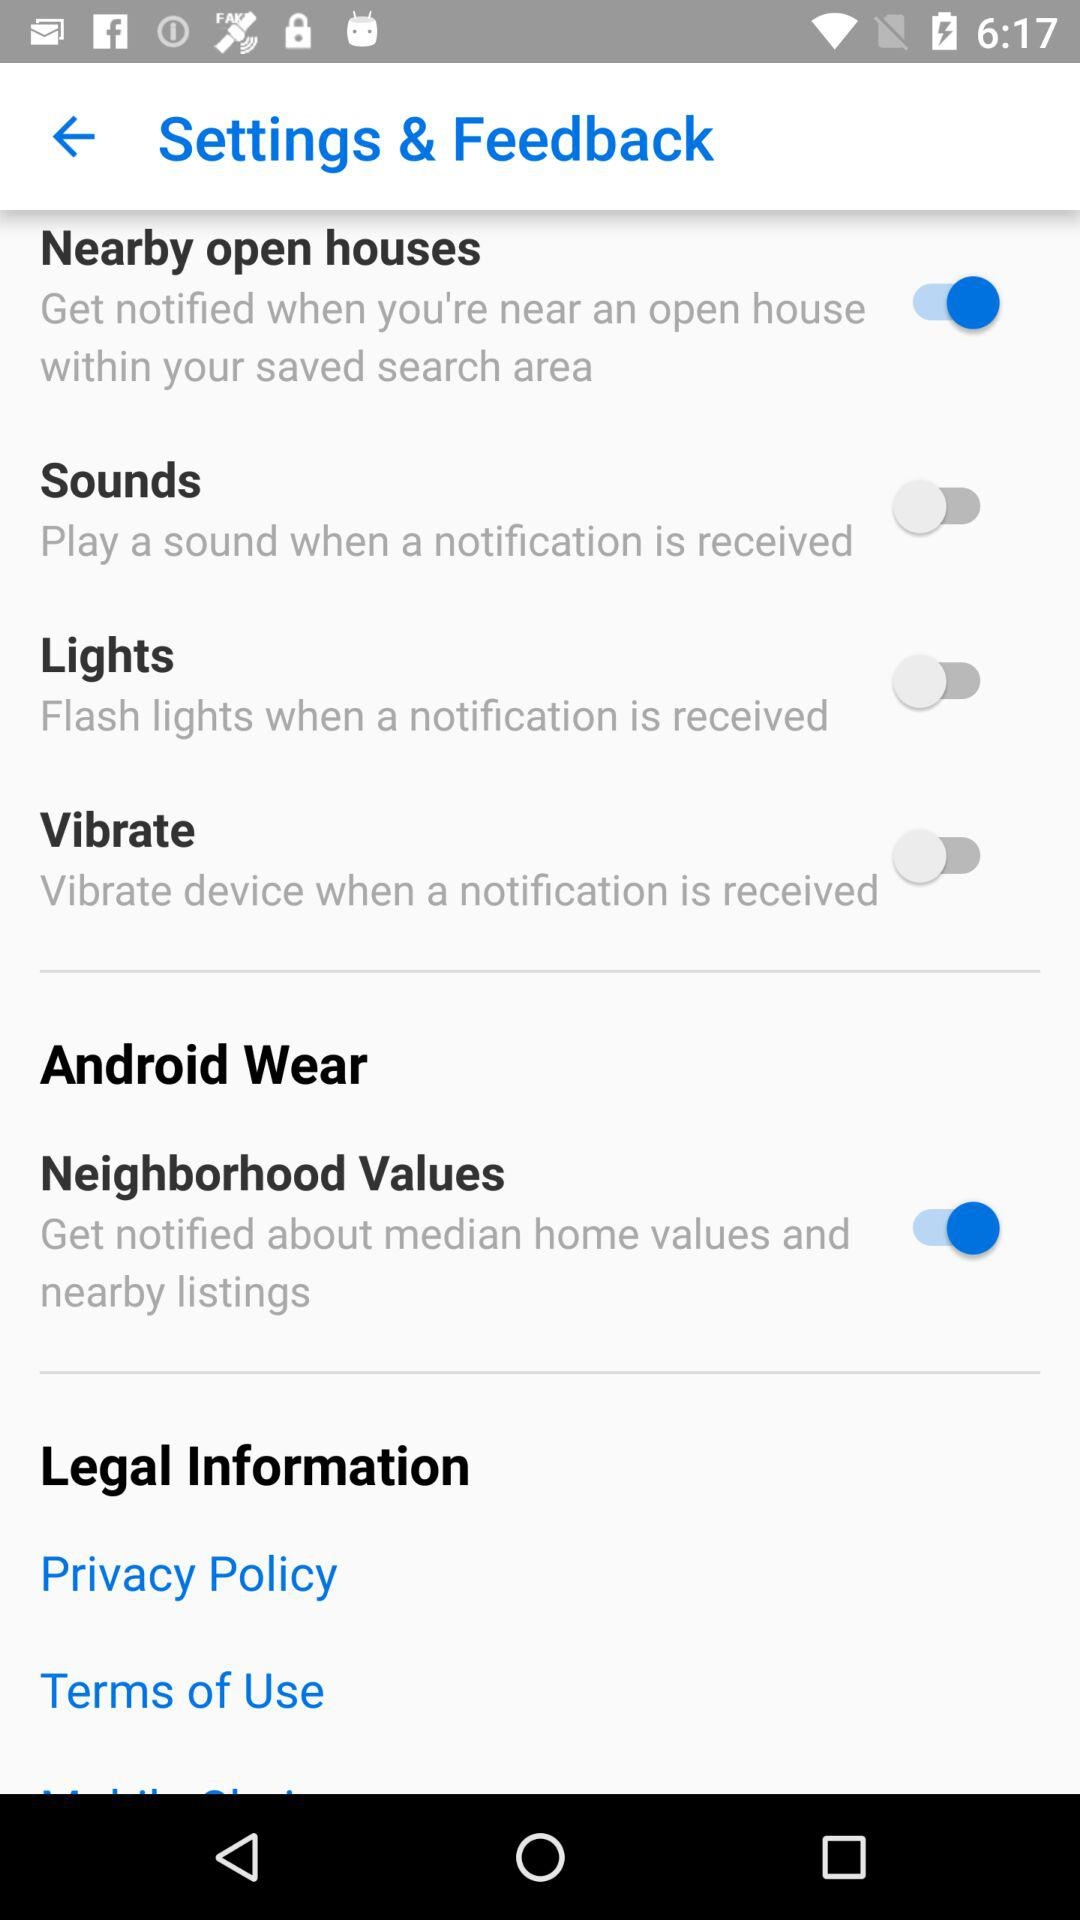What is the status of nearby open houses? The status is "on". 